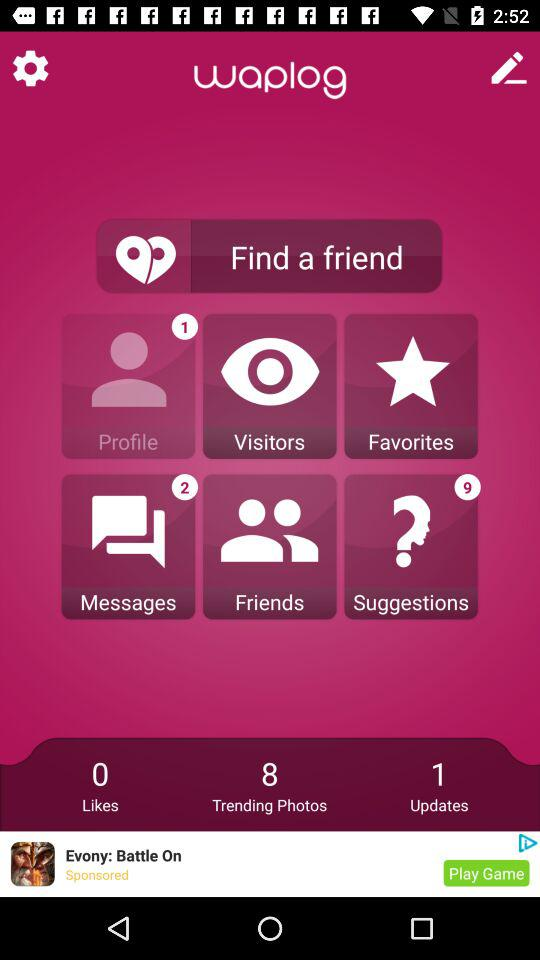What is the name of the application? The name of the application is "waplog". 